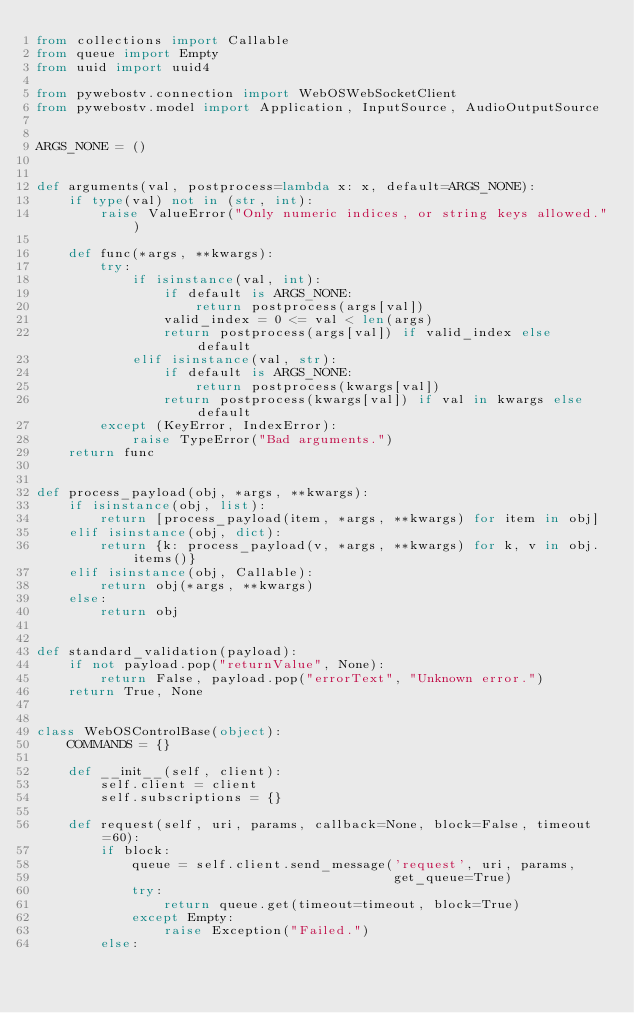<code> <loc_0><loc_0><loc_500><loc_500><_Python_>from collections import Callable
from queue import Empty
from uuid import uuid4

from pywebostv.connection import WebOSWebSocketClient
from pywebostv.model import Application, InputSource, AudioOutputSource


ARGS_NONE = ()


def arguments(val, postprocess=lambda x: x, default=ARGS_NONE):
    if type(val) not in (str, int):
        raise ValueError("Only numeric indices, or string keys allowed.")

    def func(*args, **kwargs):
        try:
            if isinstance(val, int):
                if default is ARGS_NONE:
                    return postprocess(args[val])
                valid_index = 0 <= val < len(args)
                return postprocess(args[val]) if valid_index else default
            elif isinstance(val, str):
                if default is ARGS_NONE:
                    return postprocess(kwargs[val])
                return postprocess(kwargs[val]) if val in kwargs else default
        except (KeyError, IndexError):
            raise TypeError("Bad arguments.")
    return func


def process_payload(obj, *args, **kwargs):
    if isinstance(obj, list):
        return [process_payload(item, *args, **kwargs) for item in obj]
    elif isinstance(obj, dict):
        return {k: process_payload(v, *args, **kwargs) for k, v in obj.items()}
    elif isinstance(obj, Callable):
        return obj(*args, **kwargs)
    else:
        return obj


def standard_validation(payload):
    if not payload.pop("returnValue", None):
        return False, payload.pop("errorText", "Unknown error.")
    return True, None


class WebOSControlBase(object):
    COMMANDS = {}

    def __init__(self, client):
        self.client = client
        self.subscriptions = {}

    def request(self, uri, params, callback=None, block=False, timeout=60):
        if block:
            queue = self.client.send_message('request', uri, params,
                                             get_queue=True)
            try:
                return queue.get(timeout=timeout, block=True)
            except Empty:
                raise Exception("Failed.")
        else:</code> 